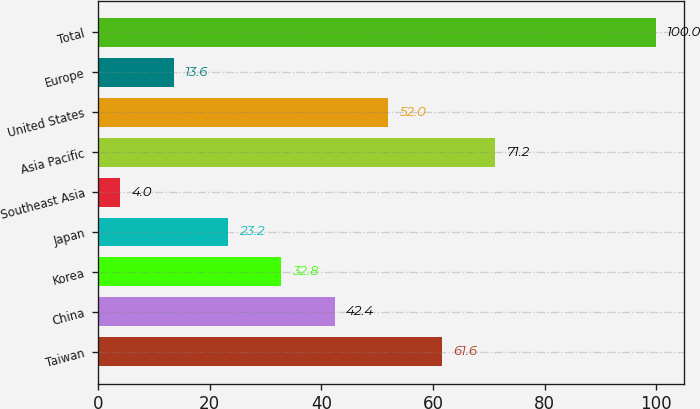<chart> <loc_0><loc_0><loc_500><loc_500><bar_chart><fcel>Taiwan<fcel>China<fcel>Korea<fcel>Japan<fcel>Southeast Asia<fcel>Asia Pacific<fcel>United States<fcel>Europe<fcel>Total<nl><fcel>61.6<fcel>42.4<fcel>32.8<fcel>23.2<fcel>4<fcel>71.2<fcel>52<fcel>13.6<fcel>100<nl></chart> 